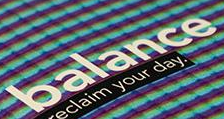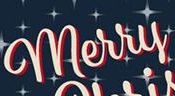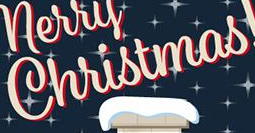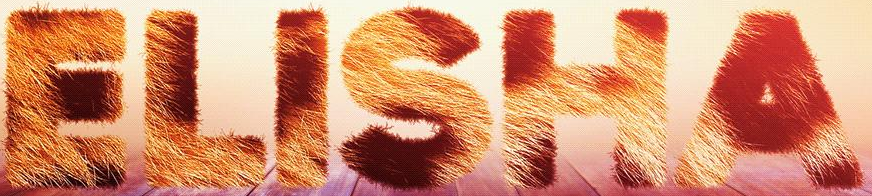What words are shown in these images in order, separated by a semicolon? balance; merry; Christmas; ELISHA 